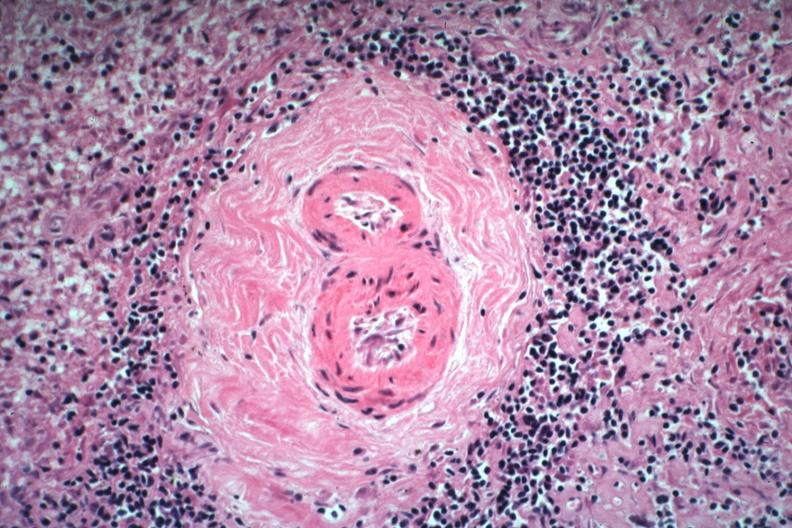s lupus erythematosus periarterial fibrosis present?
Answer the question using a single word or phrase. Yes 